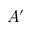Convert formula to latex. <formula><loc_0><loc_0><loc_500><loc_500>A ^ { \prime }</formula> 